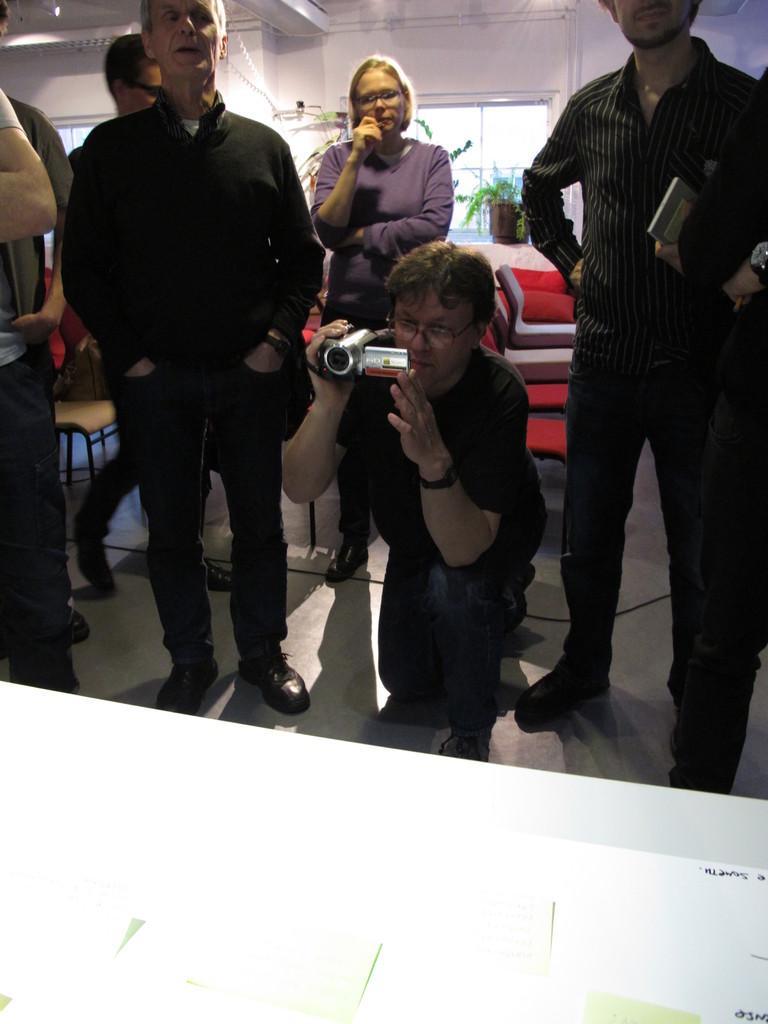In one or two sentences, can you explain what this image depicts? In this image I can see few people and one person is holding the camera. I can see few windows, flowerpot and the wall. 